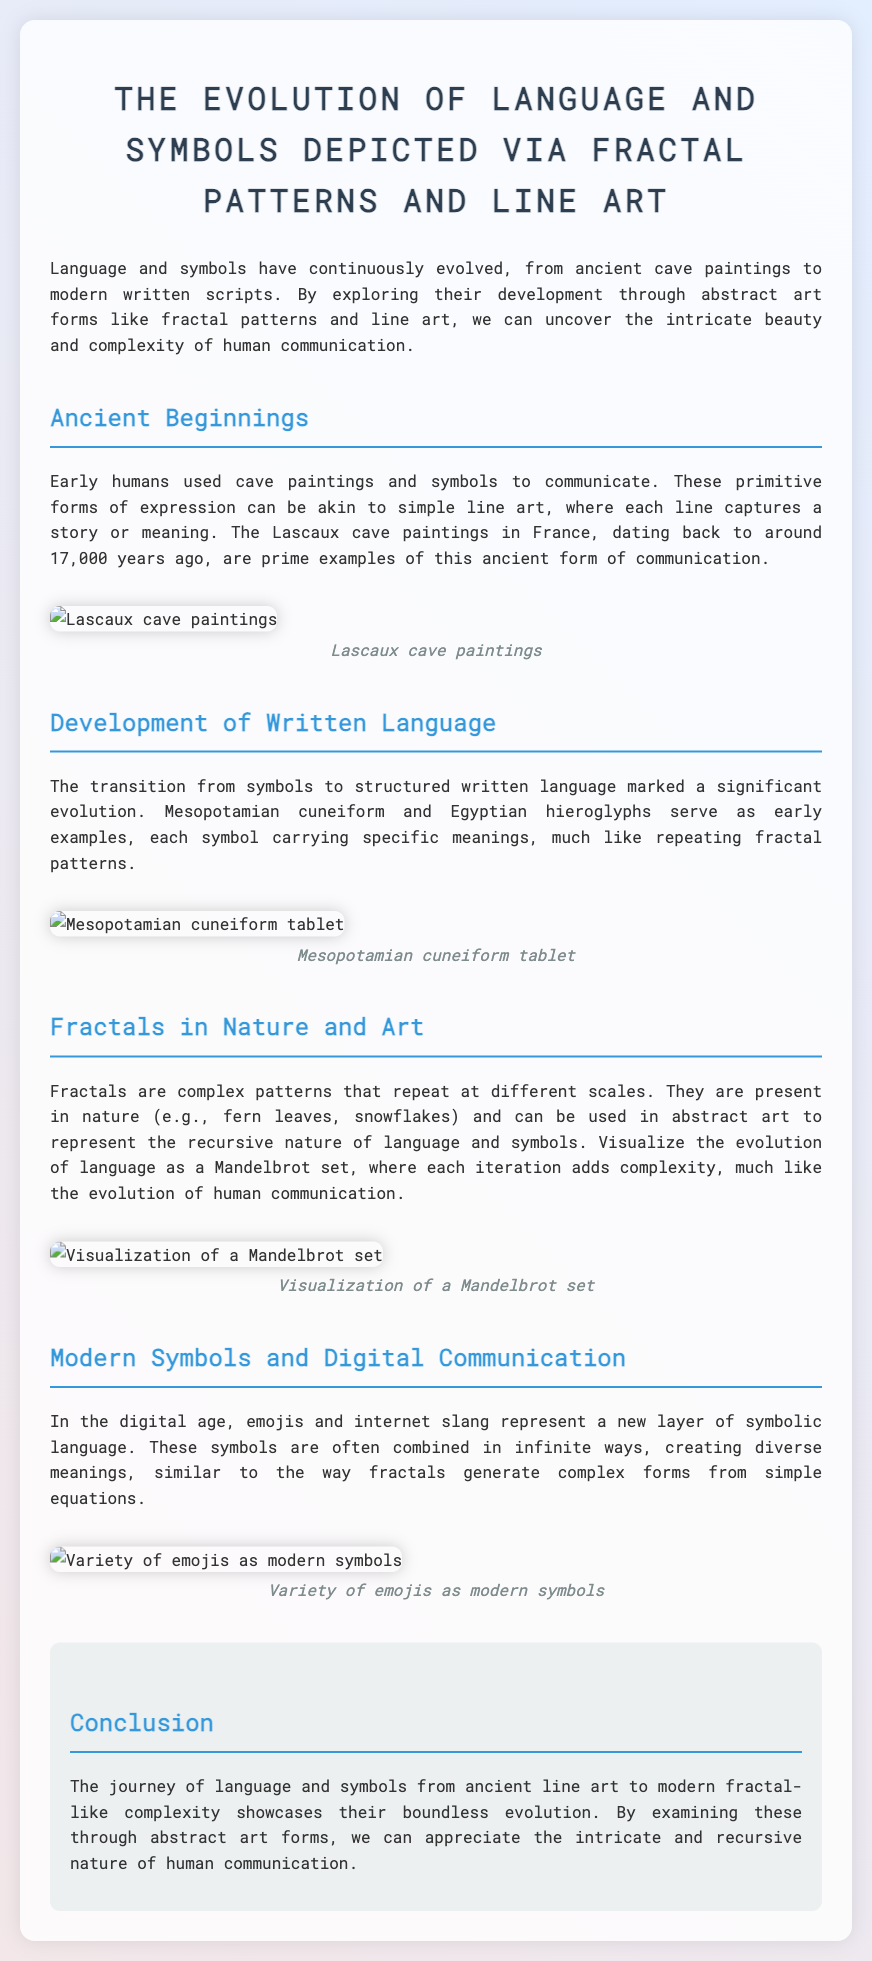What are the Lascaux cave paintings an example of? The Lascaux cave paintings represent ancient cave paintings and symbols used for communication, akin to simple line art.
Answer: Line art What are the two early examples of written language mentioned? The document mentions Mesopotamian cuneiform and Egyptian hieroglyphs as early forms of structured written language.
Answer: Cuneiform and hieroglyphs What natural phenomena are mentioned as fractals in nature? The document references fern leaves and snowflakes as examples of fractals found in nature.
Answer: Fern leaves and snowflakes What new layer of symbolic language is identified in the digital age? The document identifies emojis and internet slang as a new layer of symbolic language in the digital age.
Answer: Emojis What complex patterns are discussed in relation to language evolution? The document discusses fractals as complex patterns that can represent the recursive nature of language and symbols.
Answer: Fractals What type of art is suggested for visualizing the evolution of language? The document suggests using abstract art forms to visualize the evolution of language, indicating a connection with fractal patterns.
Answer: Abstract art In which section is the visualization of the Mandelbrot set mentioned? The visualization of the Mandelbrot set is mentioned in the section titled "Fractals in Nature and Art."
Answer: Fractals in Nature and Art What is the primary thesis of the document? The document's primary thesis discusses the evolution of language and symbols from ancient to modern forms through the lens of fractal patterns and abstract art.
Answer: Evolution of language and symbols 